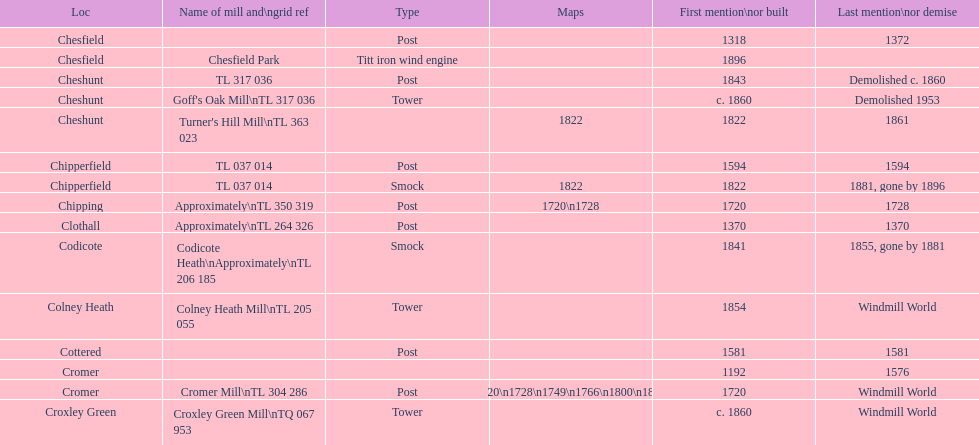What is the quantity of mills initially mentioned or constructed in the 1800s? 8. 